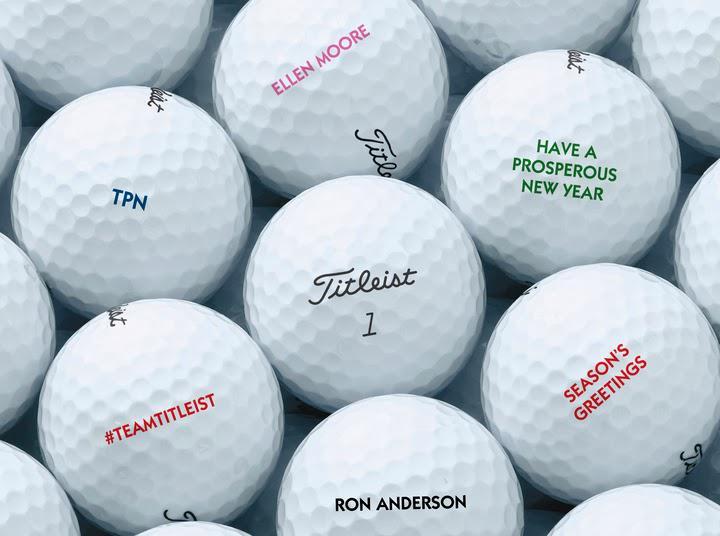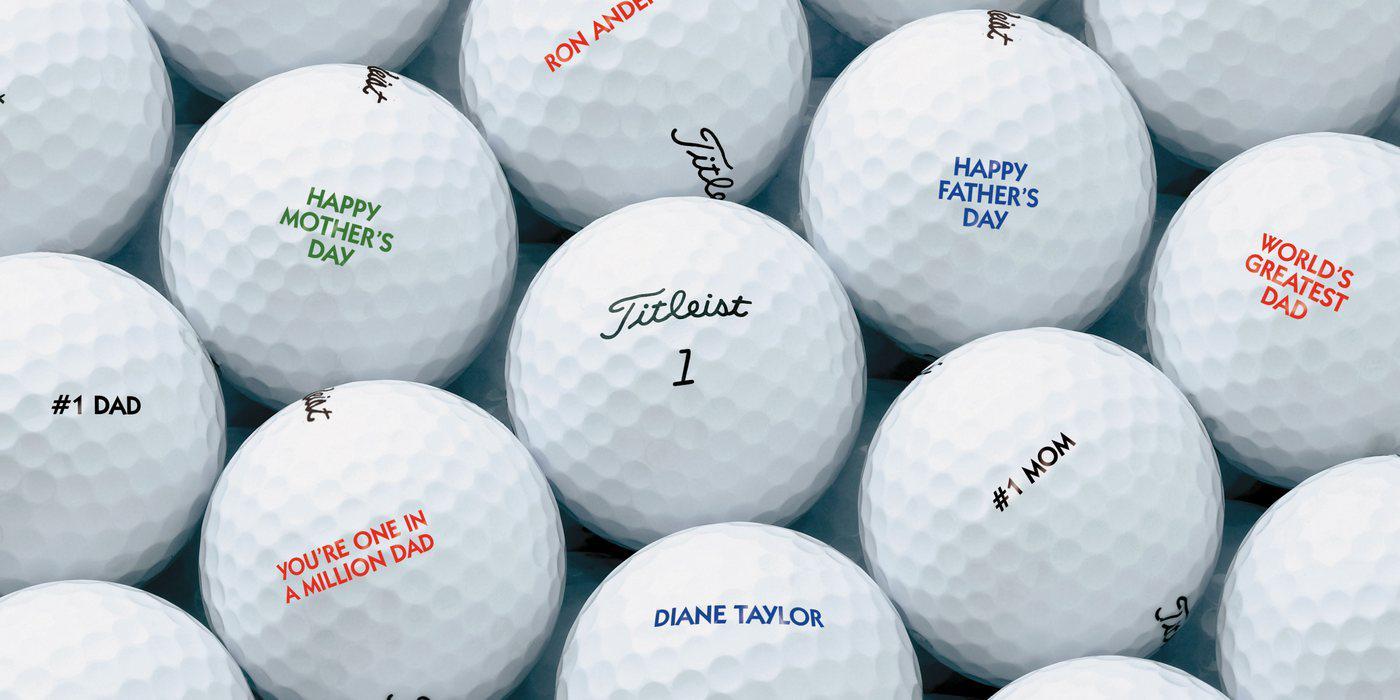The first image is the image on the left, the second image is the image on the right. Given the left and right images, does the statement "The left and right image contains a total of six golf balls." hold true? Answer yes or no. No. The first image is the image on the left, the second image is the image on the right. Examine the images to the left and right. Is the description "The combined images contain exactly six white golf balls." accurate? Answer yes or no. No. 